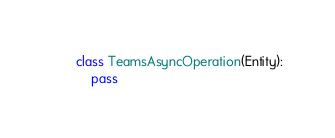<code> <loc_0><loc_0><loc_500><loc_500><_Python_>

class TeamsAsyncOperation(Entity):
    pass
</code> 